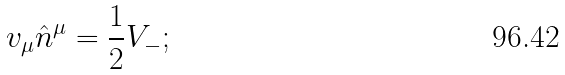Convert formula to latex. <formula><loc_0><loc_0><loc_500><loc_500>v _ { \mu } \hat { n } ^ { \mu } = \frac { 1 } { 2 } V _ { - } ;</formula> 